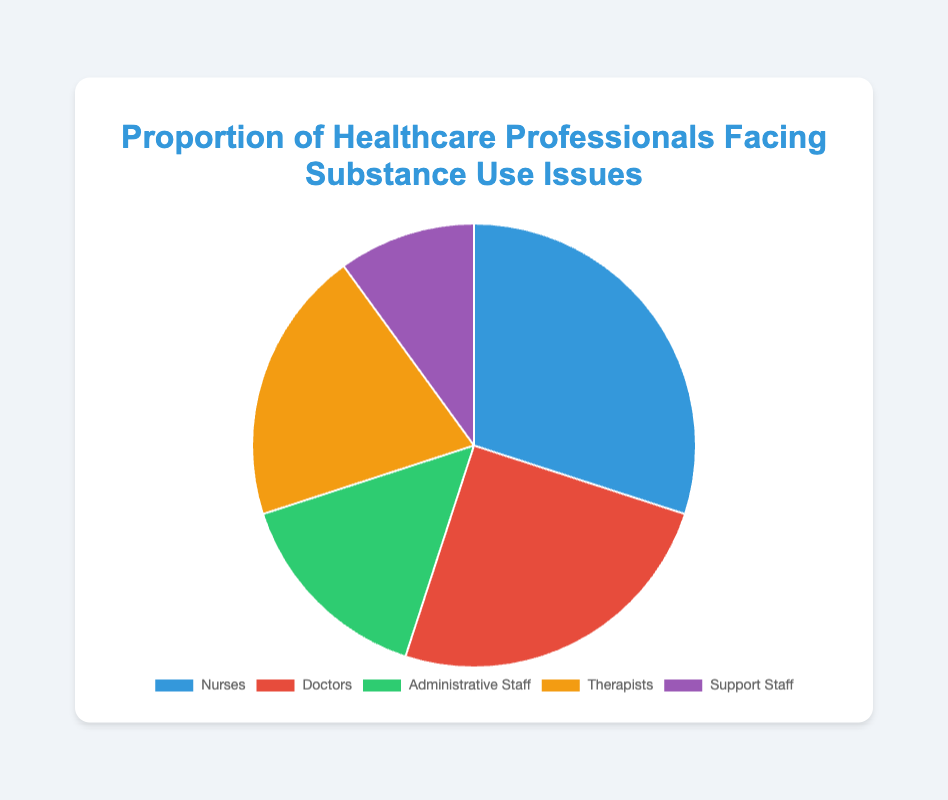What is the largest proportion of healthcare professionals facing substance use issues by profession? By looking at the pie chart, you can see that the largest segment represents the profession with the highest proportion. The largest portion of the pie chart belongs to Nurses.
Answer: Nurses Which profession has the smallest proportion of substance use issues? The smallest segment in the pie chart represents the group with the lowest proportion of substance use issues. The Support Staff segment is the smallest in the pie chart.
Answer: Support Staff What is the combined proportion of substance use issues among Administrative Staff and Support Staff? The proportions for Administrative Staff and Support Staff are 15% and 10%, respectively. Adding these together, 15 + 10 = 25%.
Answer: 25% How does the proportion of substance use issues among Doctors compare to that among Therapists? In the pie chart, the proportion of substance use issues among Doctors is 25%, and among Therapists, it is 20%. Since 25% is greater than 20%, Doctors have a higher proportion of substance use issues than Therapists.
Answer: Doctors have a higher proportion How does the proportion of substance use issues in Nurses differ from that in Support Staff? The proportion of Nurses facing substance use issues is 30%, while for Support Staff it is 10%. To find the difference, subtract 10% from 30%, which equals 20%.
Answer: 20% higher What is the total proportion of healthcare professionals facing substance use issues for professions with greater than 20% involvement? From the pie chart, Nurses have 30% and Doctors have 25%, both greater than 20%. Adding these together results in 30 + 25 = 55%.
Answer: 55% What color represents the proportion of substance use issues among Therapists? In the pie chart, each profession is represented by a distinct color. Therapists are represented by a yellow segment.
Answer: Yellow How much larger is the proportion of substance use issues in Administrative Staff compared to Support Staff? The proportion for Administrative Staff is 15%, and for Support Staff, it's 10%. Subtracting these gives 15 - 10 = 5%.
Answer: 5% larger Which two professions combined have the same proportion of substance use issues as Nurses? From the chart, Nurses have a proportion of 30%. Combining two other professions, Doctors with 25% and Support Staff with 10% gives 25 + 10 = 35%, which is not equal. Instead, combining Therapists with 20% and Administrative Staff with 15% gives 20 + 15 = 35%, which is still not equal. Thus we can say that there are no two professions whose combined proportion exactly equals that of Nurses.
Answer: No combination matches exactly 